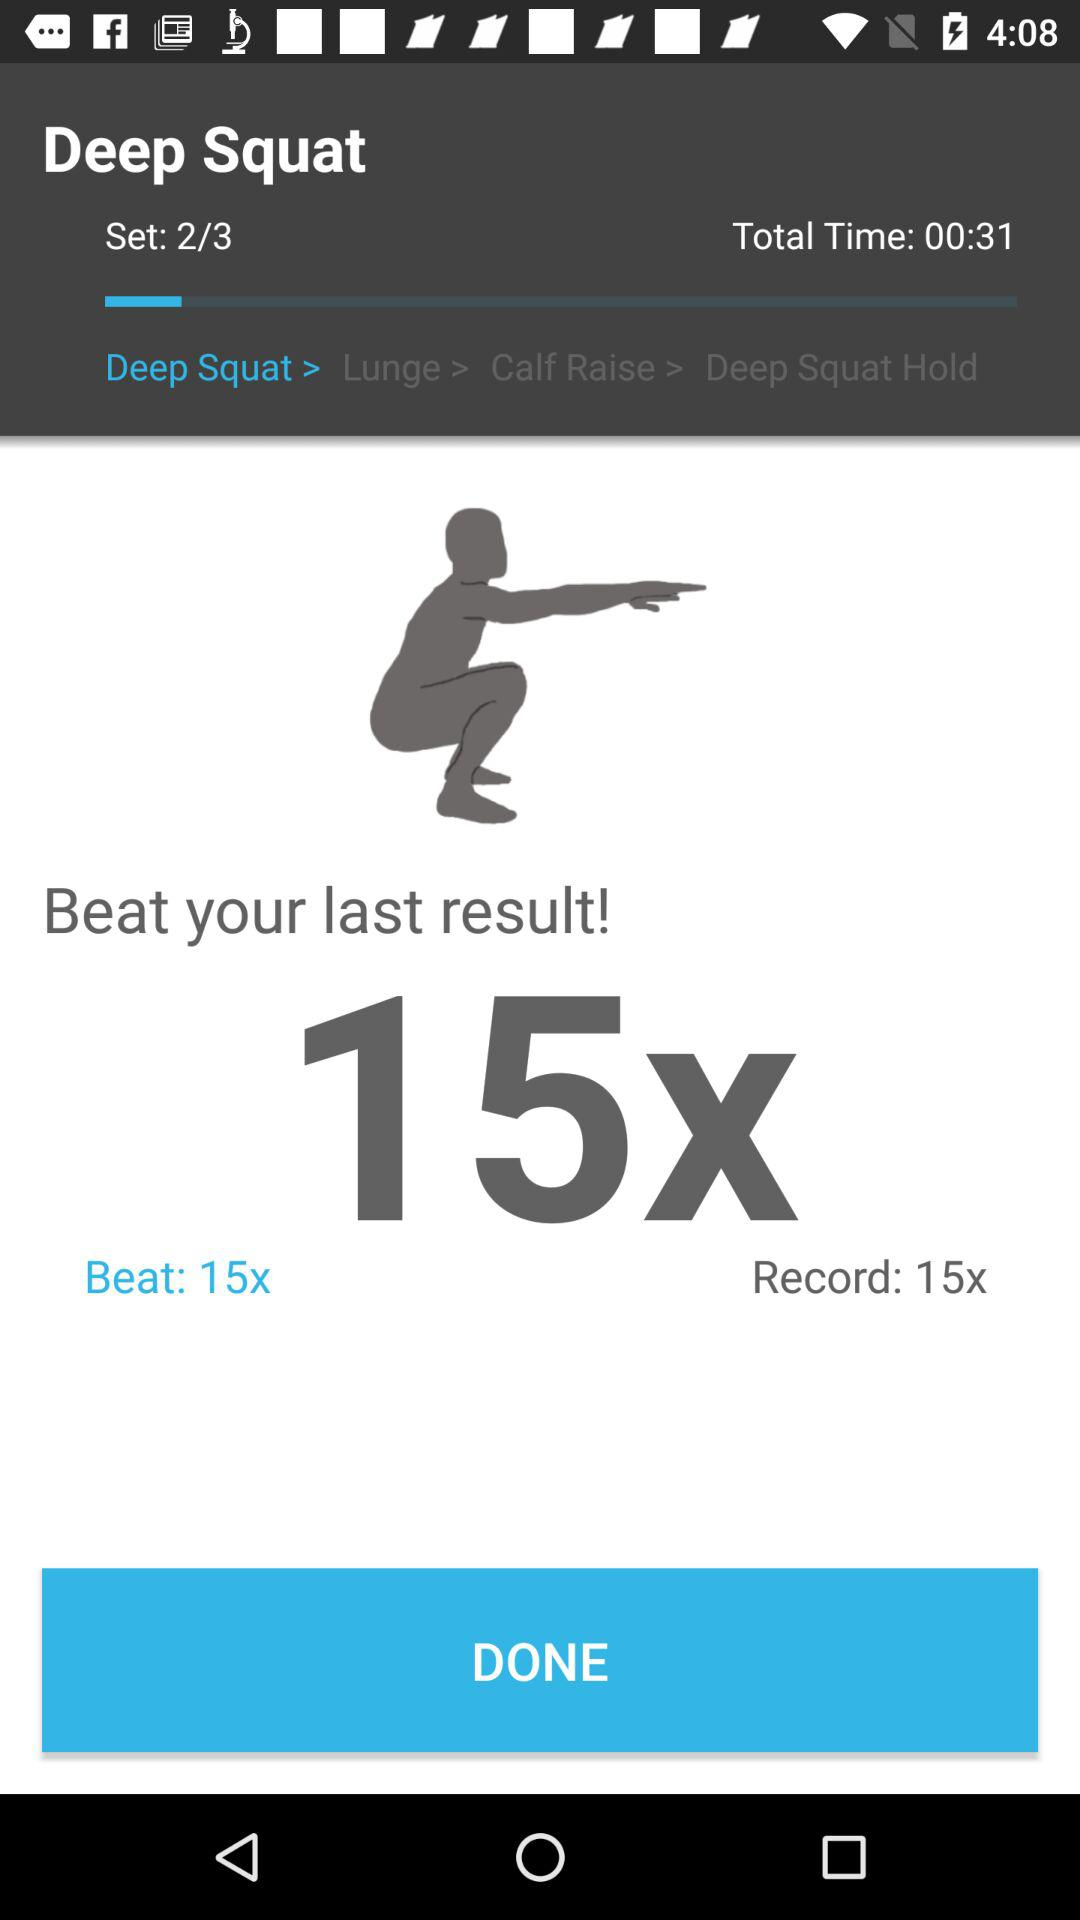What is the record? The record is 15x. 